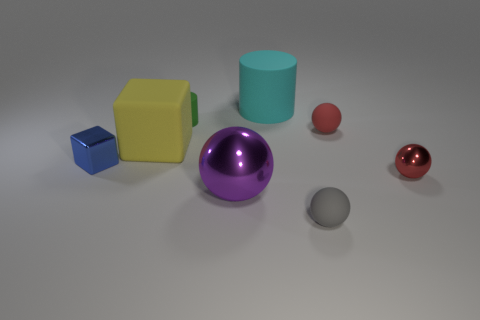How many objects are there in total, and can you describe their shapes? There are six objects in the image. Starting from the left, there is a small blue cube, a large yellow cube, a teal cylinder, a large purple sphere, a small pink sphere, and a small shiny red sphere.  Which object appears to be the largest and which one the smallest? The largest object is the purple sphere due to its visible size and volume. The smallest object is the blue cube, which is diminutive in comparison to the other objects present. 